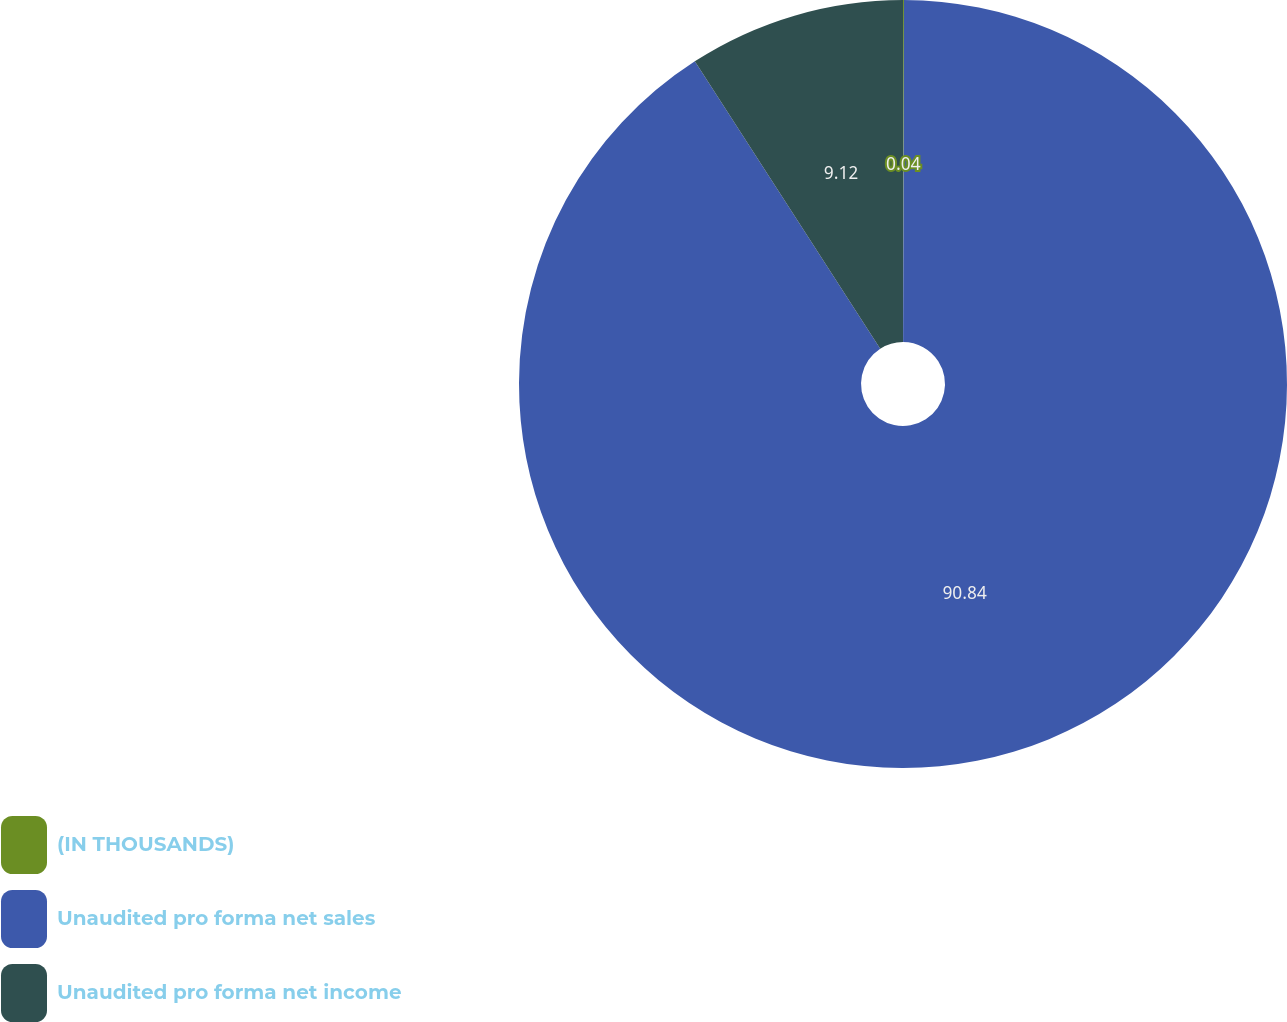<chart> <loc_0><loc_0><loc_500><loc_500><pie_chart><fcel>(IN THOUSANDS)<fcel>Unaudited pro forma net sales<fcel>Unaudited pro forma net income<nl><fcel>0.04%<fcel>90.85%<fcel>9.12%<nl></chart> 